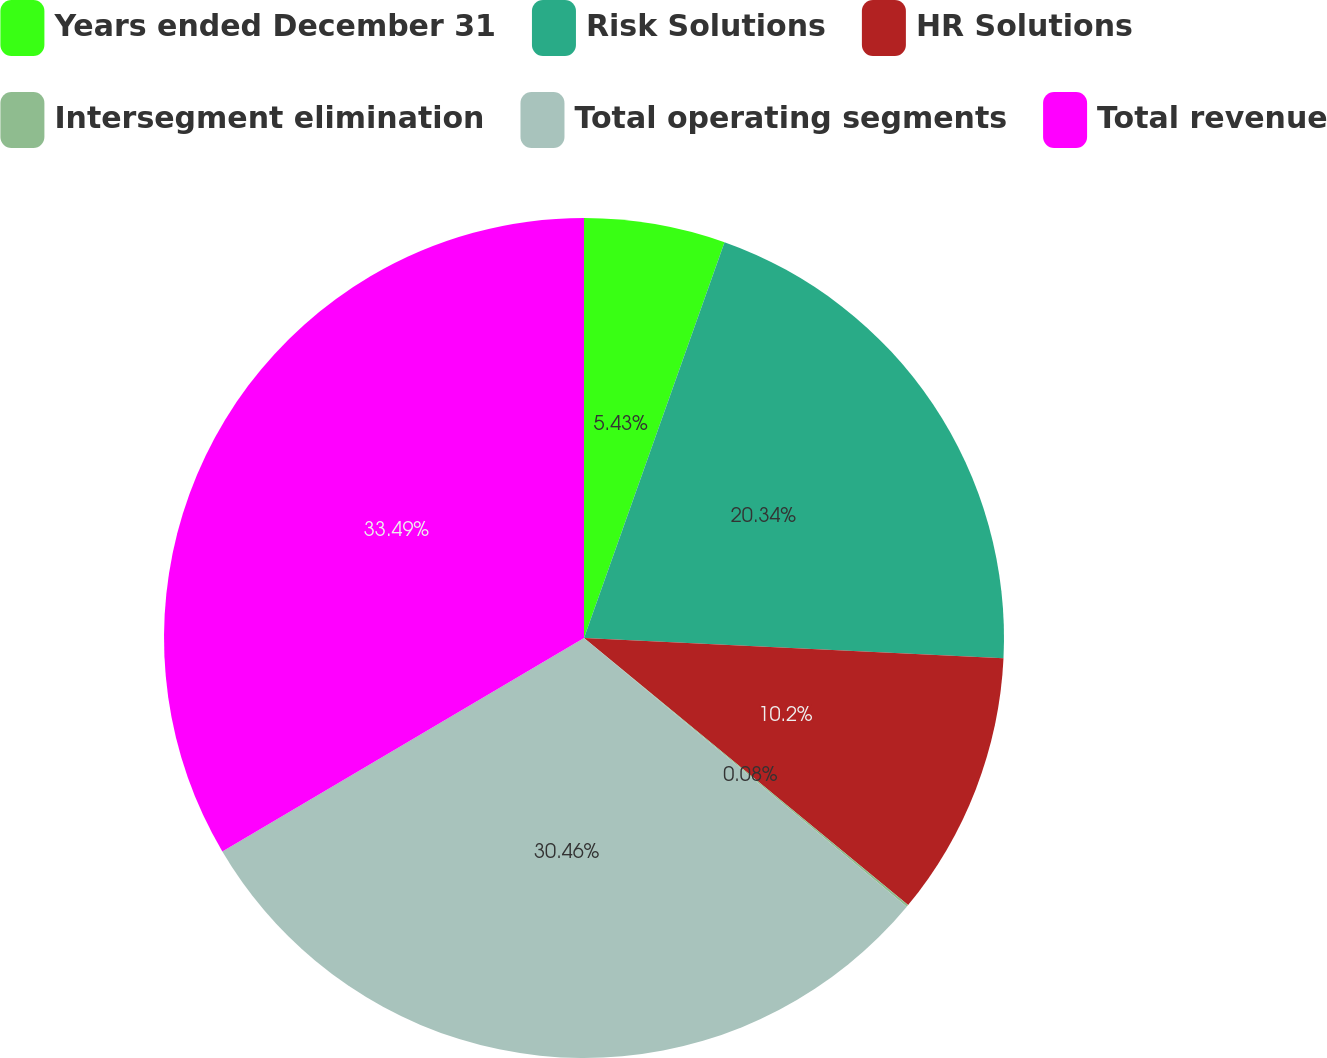Convert chart. <chart><loc_0><loc_0><loc_500><loc_500><pie_chart><fcel>Years ended December 31<fcel>Risk Solutions<fcel>HR Solutions<fcel>Intersegment elimination<fcel>Total operating segments<fcel>Total revenue<nl><fcel>5.43%<fcel>20.34%<fcel>10.2%<fcel>0.08%<fcel>30.46%<fcel>33.49%<nl></chart> 